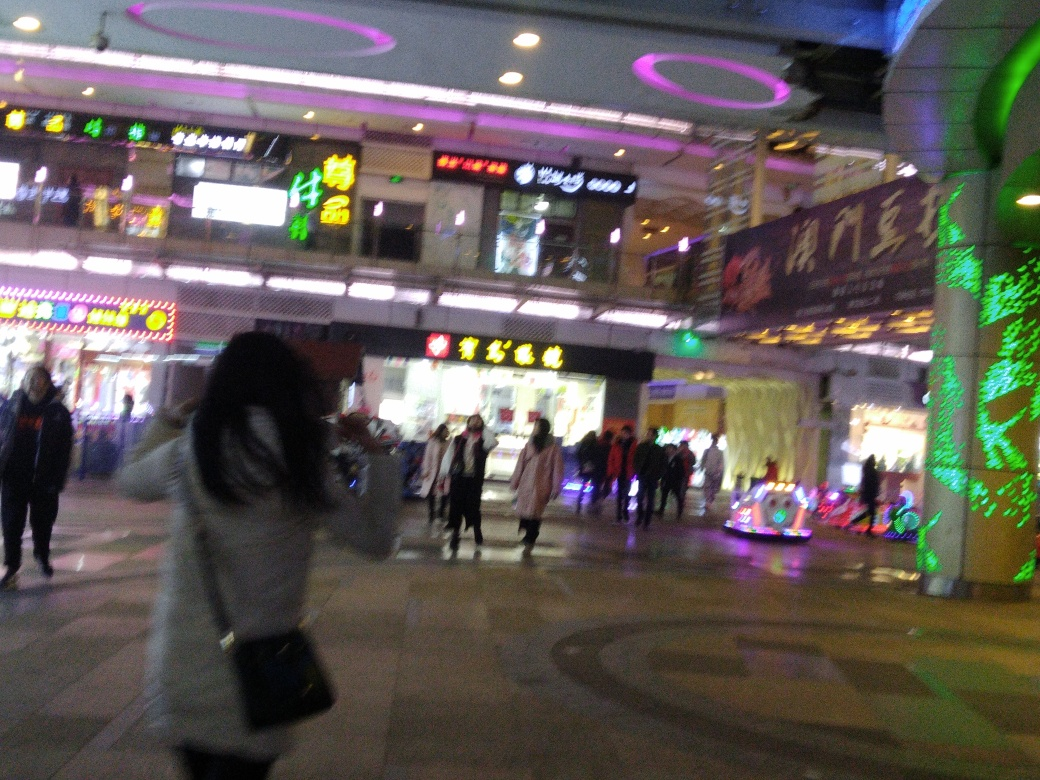Are the main subjects in the image blurry? Observing the image, it is evident that the main subjects captured, particularly the people walking and the individual taking a photograph, appear with notable motion blur, affecting the sharpness of their forms. This visual distortion typically arises from a combination of camera movement and slow shutter speed, often experienced in low-light conditions such as those apparent in this urban night setting. 